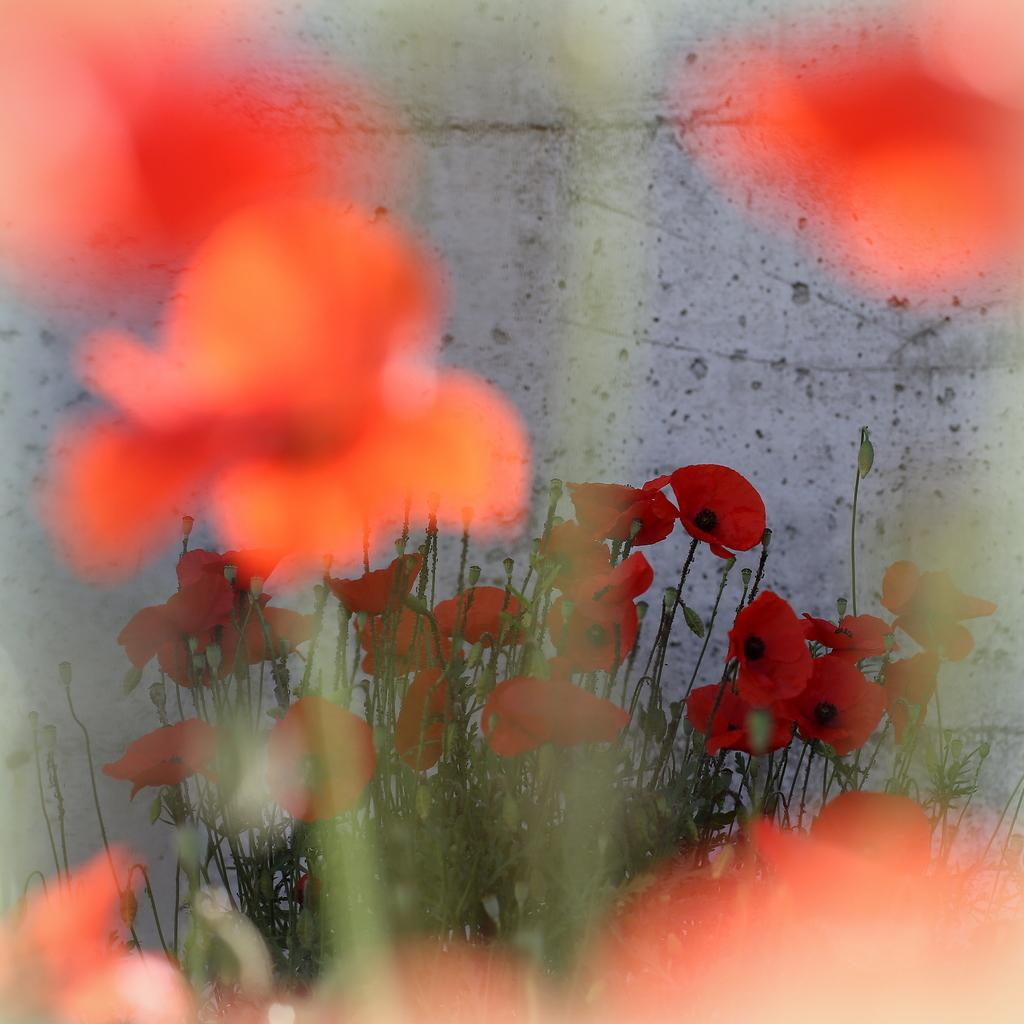What type of living organisms can be seen in the image? There are flowers in the image. What are the flowers doing in the image? The flowers are presented to plants. What is visible behind the plants in the image? There is a wall visible behind the plants in the image. What type of shirt is the person wearing while sitting on the sofa in the image? There is no person wearing a shirt or sitting on a sofa in the image; it features flowers presented to plants with a wall visible in the background. 